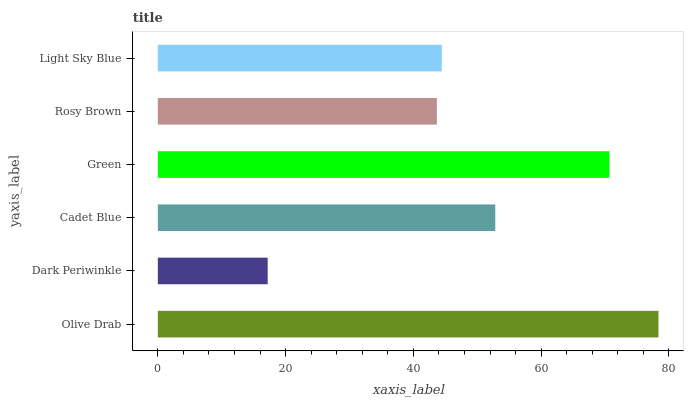Is Dark Periwinkle the minimum?
Answer yes or no. Yes. Is Olive Drab the maximum?
Answer yes or no. Yes. Is Cadet Blue the minimum?
Answer yes or no. No. Is Cadet Blue the maximum?
Answer yes or no. No. Is Cadet Blue greater than Dark Periwinkle?
Answer yes or no. Yes. Is Dark Periwinkle less than Cadet Blue?
Answer yes or no. Yes. Is Dark Periwinkle greater than Cadet Blue?
Answer yes or no. No. Is Cadet Blue less than Dark Periwinkle?
Answer yes or no. No. Is Cadet Blue the high median?
Answer yes or no. Yes. Is Light Sky Blue the low median?
Answer yes or no. Yes. Is Olive Drab the high median?
Answer yes or no. No. Is Rosy Brown the low median?
Answer yes or no. No. 